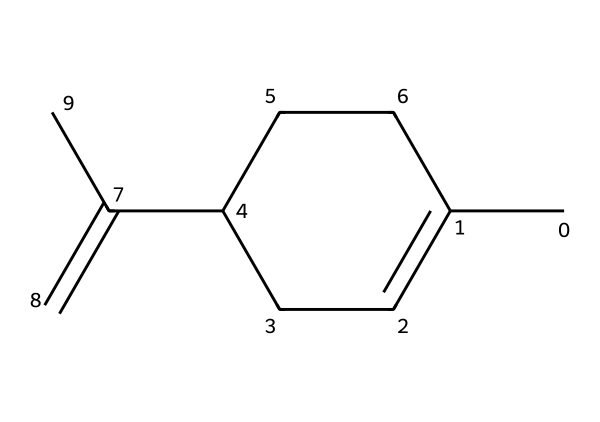What is the molecular formula of limonene? The SMILES representation CC1=CCC(CC1)C(=C)C can be analyzed to count the atoms of each element: there are 10 carbons (C) and 16 hydrogens (H). This leads us to the molecular formula C10H16.
Answer: C10H16 How many rings are present in limonene? By examining the structure represented by the SMILES, we can identify that the 'C1' indicates the presence of a cyclic structure. In this case, there is one distinct ring in limonene.
Answer: 1 What type of compound is limonene classified as? The structure demonstrates multiple carbon-carbon double bonds along with its hydrocarbon base, categorizing it as a terpene specifically a monoterpene, which typically consists of two isoprene units.
Answer: monoterpene What is the position of the double bond in the structure? In the SMILES representation, the ‘C(=C)’ indicates that the double bond is at the end of the carbon chain adjacent to the ring, specifically between the two carbons at that position.
Answer: end of the chain What is a key functional group present in the structure of limonene? The structure of limonene does not contain any heteroatoms or traditional functional groups like alcohols or ketones; its primary functional group is an alkene due to the presence of a carbon-carbon double bond.
Answer: alkene What is the boiling point trend expected for limonene among terpenes? Terpenes like limonene are generally volatile with lower boiling points than many other organic compounds, primarily due to their non-polar nature and the lack of significant intermolecular hydrogen bonding. Limonene’s specific boiling point is around 177 degrees Celsius.
Answer: 177 degrees Celsius 